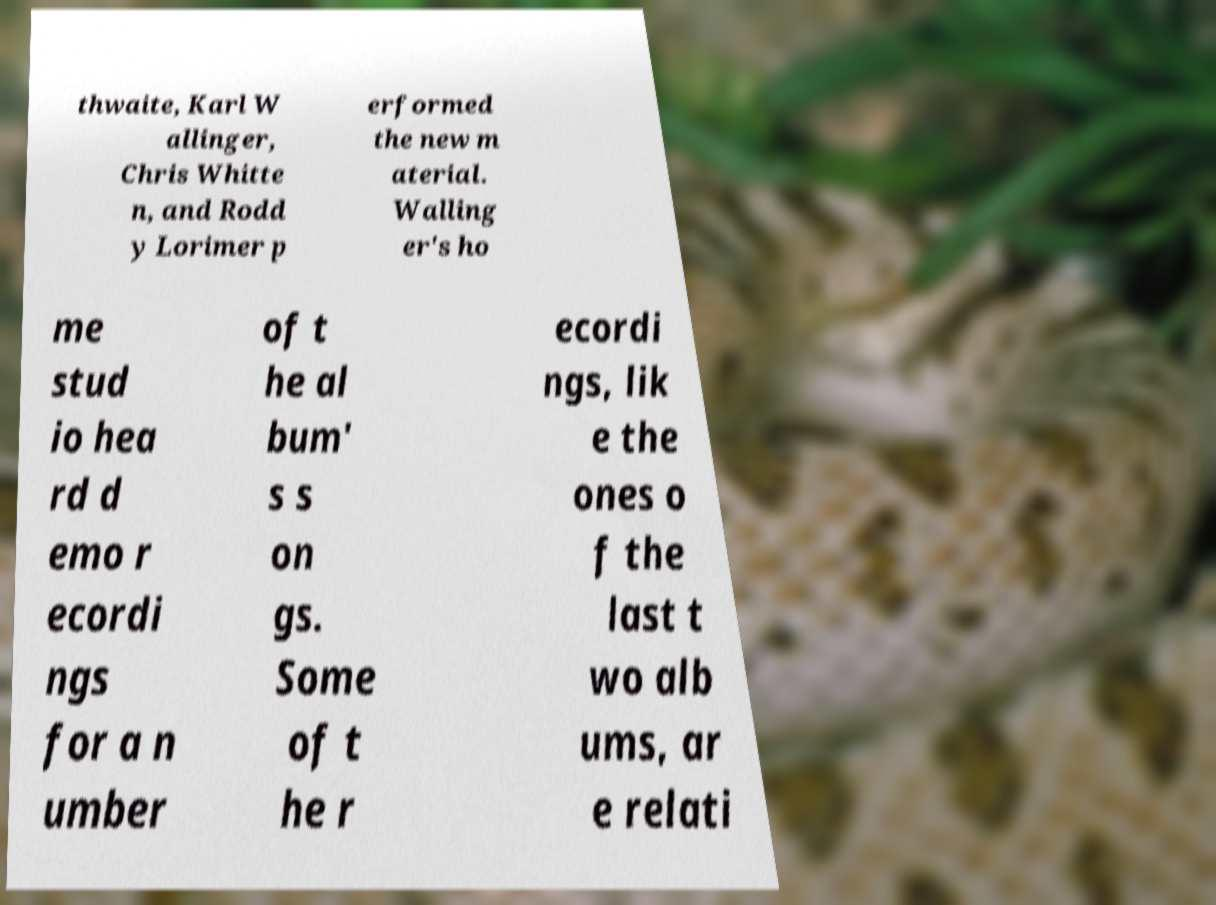Please read and relay the text visible in this image. What does it say? thwaite, Karl W allinger, Chris Whitte n, and Rodd y Lorimer p erformed the new m aterial. Walling er's ho me stud io hea rd d emo r ecordi ngs for a n umber of t he al bum' s s on gs. Some of t he r ecordi ngs, lik e the ones o f the last t wo alb ums, ar e relati 